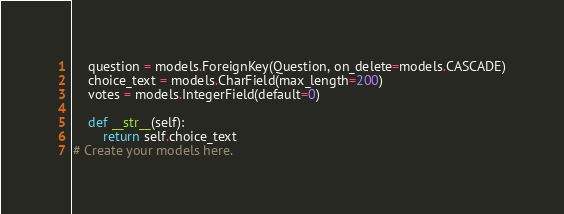<code> <loc_0><loc_0><loc_500><loc_500><_Python_>	question = models.ForeignKey(Question, on_delete=models.CASCADE)
	choice_text = models.CharField(max_length=200)
	votes = models.IntegerField(default=0)

	def __str__(self):
		return self.choice_text
# Create your models here.
</code> 